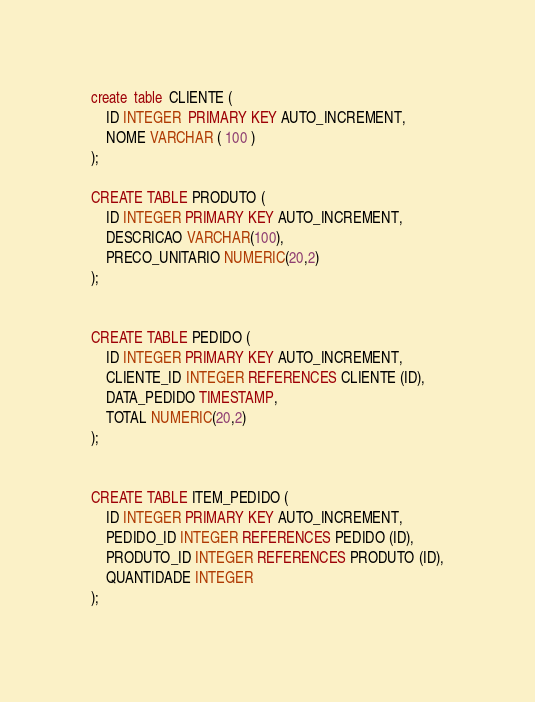Convert code to text. <code><loc_0><loc_0><loc_500><loc_500><_SQL_>create  table  CLIENTE (
    ID INTEGER  PRIMARY KEY AUTO_INCREMENT,
    NOME VARCHAR ( 100 )
);

CREATE TABLE PRODUTO (
    ID INTEGER PRIMARY KEY AUTO_INCREMENT,
    DESCRICAO VARCHAR(100),
    PRECO_UNITARIO NUMERIC(20,2)
);


CREATE TABLE PEDIDO (
    ID INTEGER PRIMARY KEY AUTO_INCREMENT,
    CLIENTE_ID INTEGER REFERENCES CLIENTE (ID),
    DATA_PEDIDO TIMESTAMP,
    TOTAL NUMERIC(20,2)
);


CREATE TABLE ITEM_PEDIDO (
    ID INTEGER PRIMARY KEY AUTO_INCREMENT,
    PEDIDO_ID INTEGER REFERENCES PEDIDO (ID),
    PRODUTO_ID INTEGER REFERENCES PRODUTO (ID),
    QUANTIDADE INTEGER
);
</code> 